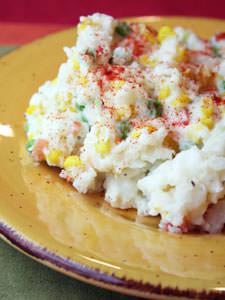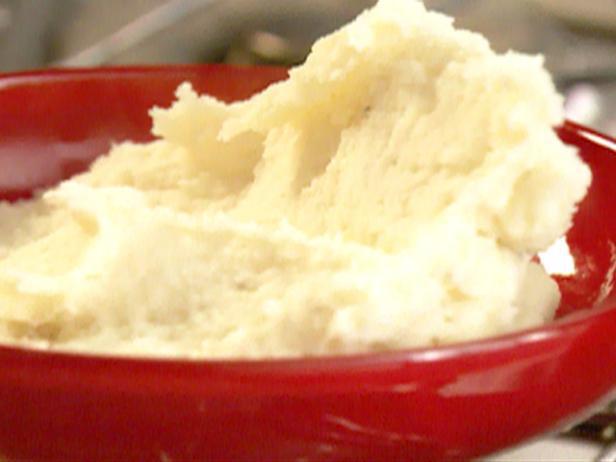The first image is the image on the left, the second image is the image on the right. Given the left and right images, does the statement "The right image shows mashed potatoes served in a bright red bowl, and no image shows a green garnish sprig on top of mashed potatoes." hold true? Answer yes or no. Yes. The first image is the image on the left, the second image is the image on the right. Analyze the images presented: Is the assertion "The right image contains a bowl of mashed potatoes with a spoon handle sticking out of  it." valid? Answer yes or no. No. 